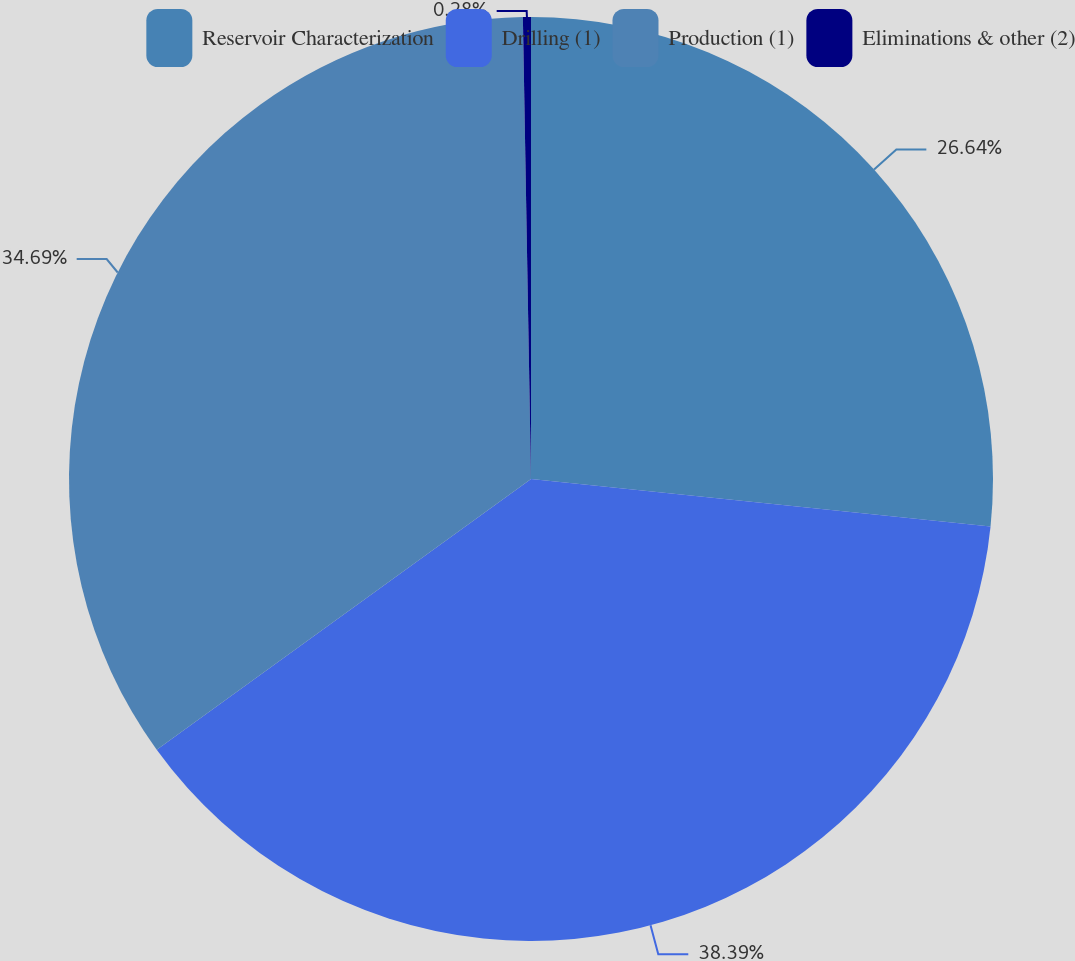Convert chart. <chart><loc_0><loc_0><loc_500><loc_500><pie_chart><fcel>Reservoir Characterization<fcel>Drilling (1)<fcel>Production (1)<fcel>Eliminations & other (2)<nl><fcel>26.64%<fcel>38.39%<fcel>34.69%<fcel>0.28%<nl></chart> 